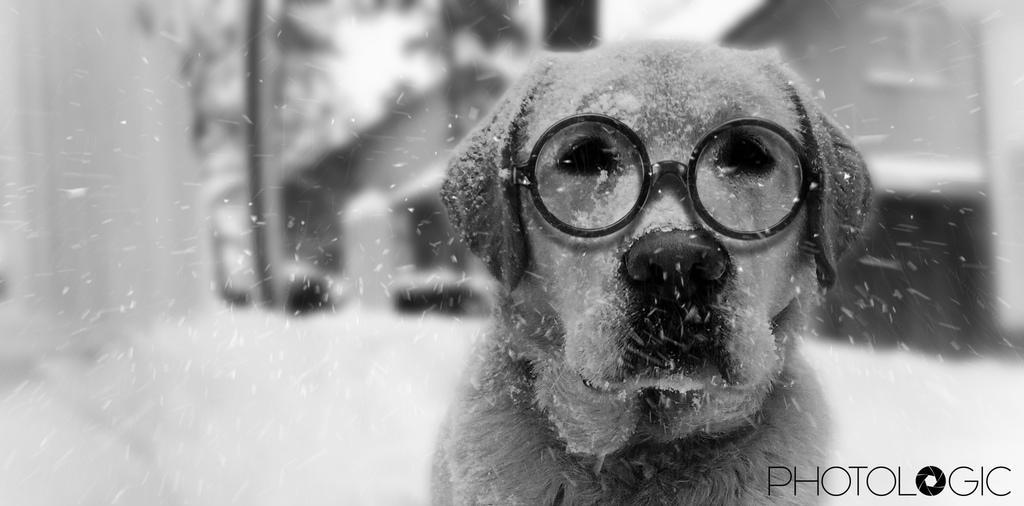Could you give a brief overview of what you see in this image? In this black and white image, we can see a dog wearing spectacles. There is a text in the bottom right of the image. In the background, image is blurred. 